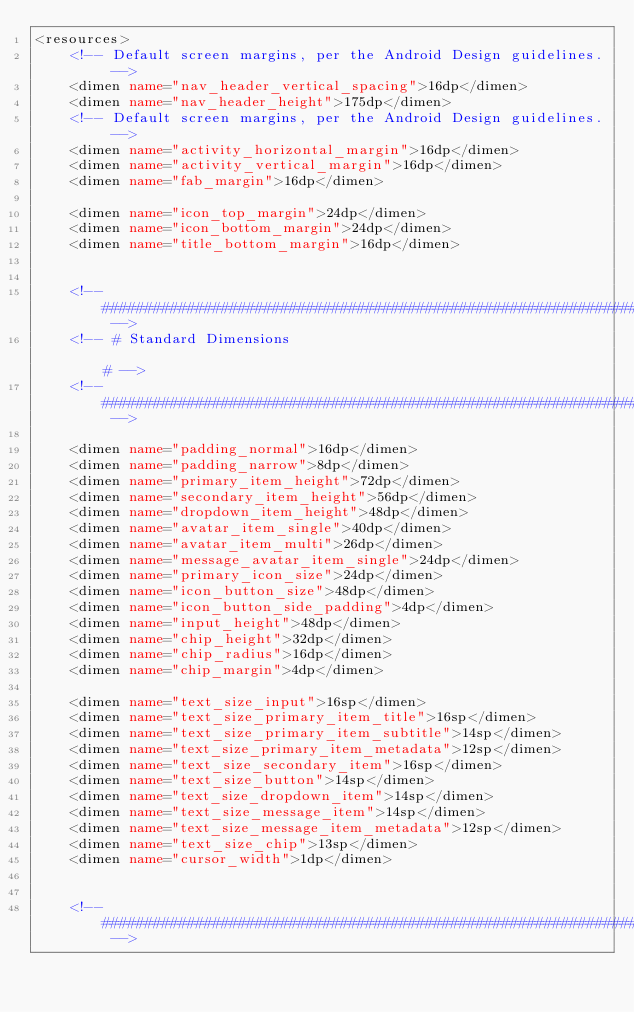Convert code to text. <code><loc_0><loc_0><loc_500><loc_500><_XML_><resources>
    <!-- Default screen margins, per the Android Design guidelines. -->
    <dimen name="nav_header_vertical_spacing">16dp</dimen>
    <dimen name="nav_header_height">175dp</dimen>
    <!-- Default screen margins, per the Android Design guidelines. -->
    <dimen name="activity_horizontal_margin">16dp</dimen>
    <dimen name="activity_vertical_margin">16dp</dimen>
    <dimen name="fab_margin">16dp</dimen>

    <dimen name="icon_top_margin">24dp</dimen>
    <dimen name="icon_bottom_margin">24dp</dimen>
    <dimen name="title_bottom_margin">16dp</dimen>


    <!-- ####################################################################################### -->
    <!-- # Standard Dimensions                                                                 # -->
    <!-- ####################################################################################### -->

    <dimen name="padding_normal">16dp</dimen>
    <dimen name="padding_narrow">8dp</dimen>
    <dimen name="primary_item_height">72dp</dimen>
    <dimen name="secondary_item_height">56dp</dimen>
    <dimen name="dropdown_item_height">48dp</dimen>
    <dimen name="avatar_item_single">40dp</dimen>
    <dimen name="avatar_item_multi">26dp</dimen>
    <dimen name="message_avatar_item_single">24dp</dimen>
    <dimen name="primary_icon_size">24dp</dimen>
    <dimen name="icon_button_size">48dp</dimen>
    <dimen name="icon_button_side_padding">4dp</dimen>
    <dimen name="input_height">48dp</dimen>
    <dimen name="chip_height">32dp</dimen>
    <dimen name="chip_radius">16dp</dimen>
    <dimen name="chip_margin">4dp</dimen>

    <dimen name="text_size_input">16sp</dimen>
    <dimen name="text_size_primary_item_title">16sp</dimen>
    <dimen name="text_size_primary_item_subtitle">14sp</dimen>
    <dimen name="text_size_primary_item_metadata">12sp</dimen>
    <dimen name="text_size_secondary_item">16sp</dimen>
    <dimen name="text_size_button">14sp</dimen>
    <dimen name="text_size_dropdown_item">14sp</dimen>
    <dimen name="text_size_message_item">14sp</dimen>
    <dimen name="text_size_message_item_metadata">12sp</dimen>
    <dimen name="text_size_chip">13sp</dimen>
    <dimen name="cursor_width">1dp</dimen>


    <!-- ####################################################################################### --></code> 